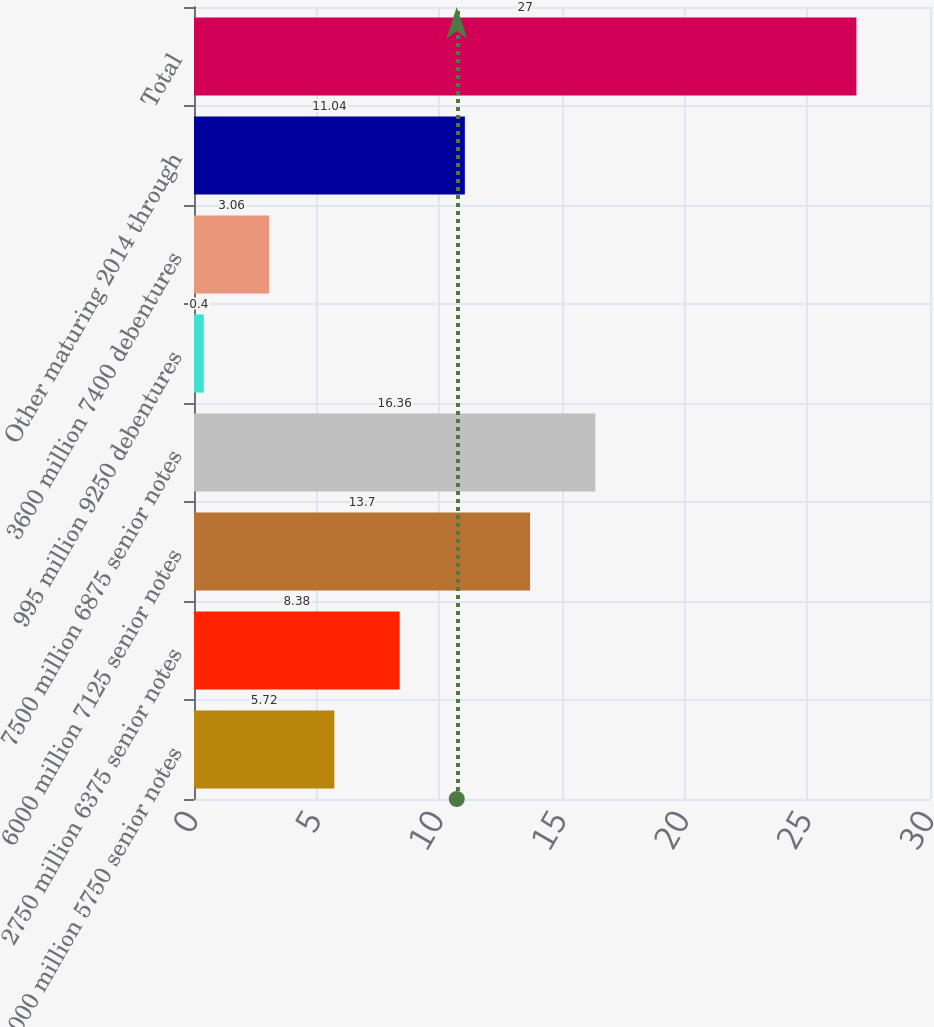Convert chart. <chart><loc_0><loc_0><loc_500><loc_500><bar_chart><fcel>4000 million 5750 senior notes<fcel>2750 million 6375 senior notes<fcel>6000 million 7125 senior notes<fcel>7500 million 6875 senior notes<fcel>995 million 9250 debentures<fcel>3600 million 7400 debentures<fcel>Other maturing 2014 through<fcel>Total<nl><fcel>5.72<fcel>8.38<fcel>13.7<fcel>16.36<fcel>0.4<fcel>3.06<fcel>11.04<fcel>27<nl></chart> 